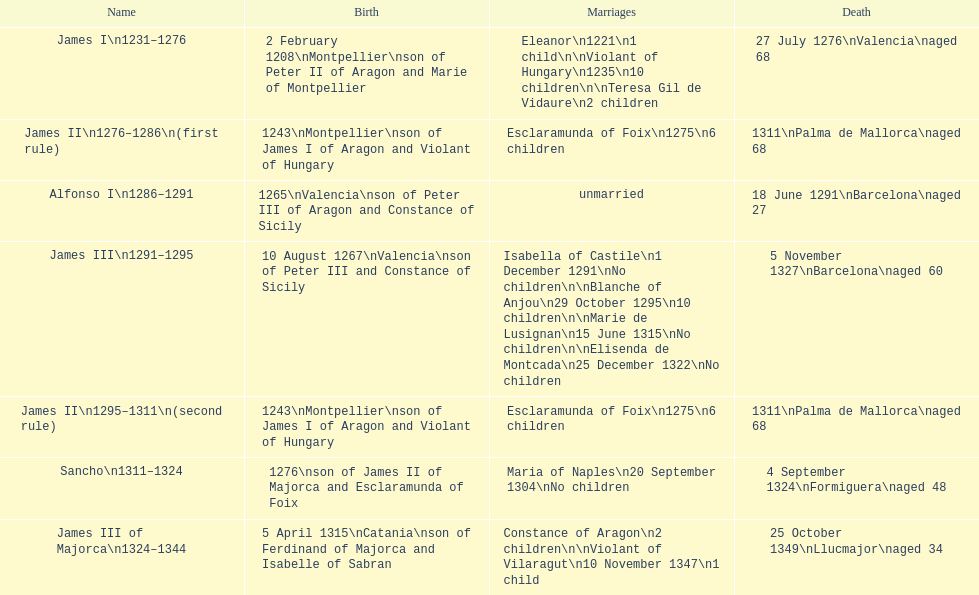Was james iii or sancho born in the year 1276? Sancho. 